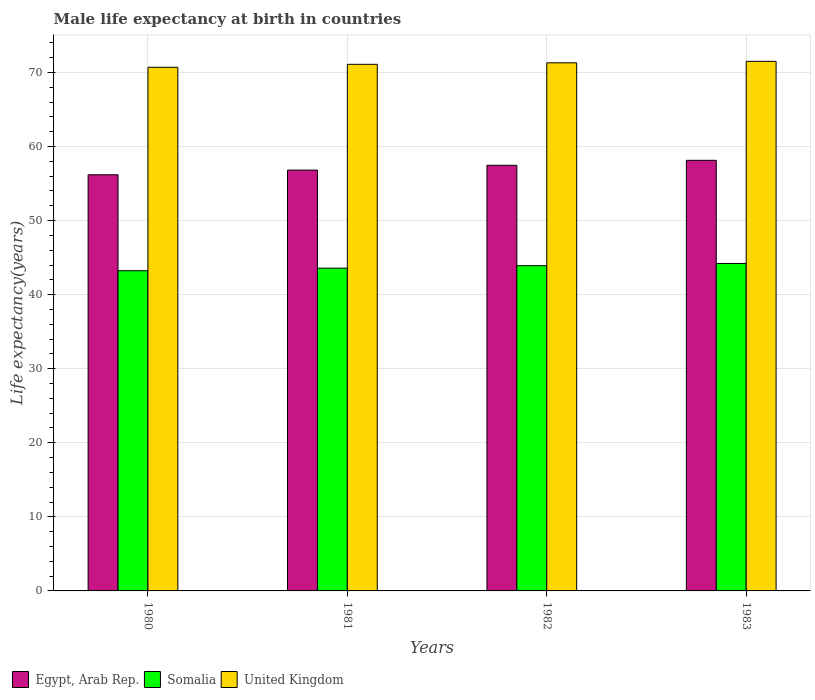Are the number of bars per tick equal to the number of legend labels?
Your answer should be compact. Yes. Are the number of bars on each tick of the X-axis equal?
Make the answer very short. Yes. How many bars are there on the 1st tick from the left?
Offer a terse response. 3. In how many cases, is the number of bars for a given year not equal to the number of legend labels?
Your answer should be very brief. 0. What is the male life expectancy at birth in Somalia in 1982?
Ensure brevity in your answer.  43.91. Across all years, what is the maximum male life expectancy at birth in Egypt, Arab Rep.?
Your response must be concise. 58.14. Across all years, what is the minimum male life expectancy at birth in United Kingdom?
Provide a short and direct response. 70.7. In which year was the male life expectancy at birth in Somalia maximum?
Your answer should be very brief. 1983. What is the total male life expectancy at birth in Somalia in the graph?
Make the answer very short. 174.93. What is the difference between the male life expectancy at birth in Somalia in 1981 and that in 1982?
Give a very brief answer. -0.33. What is the difference between the male life expectancy at birth in United Kingdom in 1981 and the male life expectancy at birth in Somalia in 1982?
Offer a very short reply. 27.19. What is the average male life expectancy at birth in Somalia per year?
Ensure brevity in your answer.  43.73. In the year 1982, what is the difference between the male life expectancy at birth in United Kingdom and male life expectancy at birth in Egypt, Arab Rep.?
Your answer should be compact. 13.84. In how many years, is the male life expectancy at birth in United Kingdom greater than 46 years?
Offer a very short reply. 4. What is the ratio of the male life expectancy at birth in United Kingdom in 1980 to that in 1981?
Make the answer very short. 0.99. Is the difference between the male life expectancy at birth in United Kingdom in 1980 and 1982 greater than the difference between the male life expectancy at birth in Egypt, Arab Rep. in 1980 and 1982?
Keep it short and to the point. Yes. What is the difference between the highest and the second highest male life expectancy at birth in Egypt, Arab Rep.?
Ensure brevity in your answer.  0.67. What is the difference between the highest and the lowest male life expectancy at birth in Somalia?
Ensure brevity in your answer.  0.98. Is the sum of the male life expectancy at birth in United Kingdom in 1980 and 1982 greater than the maximum male life expectancy at birth in Somalia across all years?
Give a very brief answer. Yes. What does the 1st bar from the left in 1982 represents?
Provide a short and direct response. Egypt, Arab Rep. What does the 1st bar from the right in 1981 represents?
Give a very brief answer. United Kingdom. How many bars are there?
Keep it short and to the point. 12. Are all the bars in the graph horizontal?
Make the answer very short. No. Does the graph contain grids?
Your answer should be very brief. Yes. How many legend labels are there?
Keep it short and to the point. 3. What is the title of the graph?
Provide a short and direct response. Male life expectancy at birth in countries. What is the label or title of the Y-axis?
Give a very brief answer. Life expectancy(years). What is the Life expectancy(years) of Egypt, Arab Rep. in 1980?
Make the answer very short. 56.19. What is the Life expectancy(years) in Somalia in 1980?
Provide a succinct answer. 43.23. What is the Life expectancy(years) of United Kingdom in 1980?
Provide a short and direct response. 70.7. What is the Life expectancy(years) in Egypt, Arab Rep. in 1981?
Provide a succinct answer. 56.82. What is the Life expectancy(years) of Somalia in 1981?
Make the answer very short. 43.58. What is the Life expectancy(years) of United Kingdom in 1981?
Your answer should be very brief. 71.1. What is the Life expectancy(years) in Egypt, Arab Rep. in 1982?
Your response must be concise. 57.46. What is the Life expectancy(years) of Somalia in 1982?
Keep it short and to the point. 43.91. What is the Life expectancy(years) in United Kingdom in 1982?
Offer a very short reply. 71.3. What is the Life expectancy(years) of Egypt, Arab Rep. in 1983?
Offer a very short reply. 58.14. What is the Life expectancy(years) in Somalia in 1983?
Provide a succinct answer. 44.21. What is the Life expectancy(years) in United Kingdom in 1983?
Make the answer very short. 71.5. Across all years, what is the maximum Life expectancy(years) in Egypt, Arab Rep.?
Keep it short and to the point. 58.14. Across all years, what is the maximum Life expectancy(years) of Somalia?
Offer a very short reply. 44.21. Across all years, what is the maximum Life expectancy(years) in United Kingdom?
Offer a terse response. 71.5. Across all years, what is the minimum Life expectancy(years) in Egypt, Arab Rep.?
Your answer should be compact. 56.19. Across all years, what is the minimum Life expectancy(years) of Somalia?
Offer a very short reply. 43.23. Across all years, what is the minimum Life expectancy(years) of United Kingdom?
Offer a terse response. 70.7. What is the total Life expectancy(years) in Egypt, Arab Rep. in the graph?
Make the answer very short. 228.61. What is the total Life expectancy(years) in Somalia in the graph?
Offer a terse response. 174.93. What is the total Life expectancy(years) in United Kingdom in the graph?
Your answer should be compact. 284.6. What is the difference between the Life expectancy(years) of Egypt, Arab Rep. in 1980 and that in 1981?
Your answer should be compact. -0.63. What is the difference between the Life expectancy(years) in Somalia in 1980 and that in 1981?
Your answer should be very brief. -0.35. What is the difference between the Life expectancy(years) of Egypt, Arab Rep. in 1980 and that in 1982?
Ensure brevity in your answer.  -1.27. What is the difference between the Life expectancy(years) of Somalia in 1980 and that in 1982?
Your answer should be very brief. -0.68. What is the difference between the Life expectancy(years) of United Kingdom in 1980 and that in 1982?
Keep it short and to the point. -0.6. What is the difference between the Life expectancy(years) in Egypt, Arab Rep. in 1980 and that in 1983?
Offer a terse response. -1.95. What is the difference between the Life expectancy(years) in Somalia in 1980 and that in 1983?
Your answer should be compact. -0.98. What is the difference between the Life expectancy(years) of Egypt, Arab Rep. in 1981 and that in 1982?
Provide a succinct answer. -0.65. What is the difference between the Life expectancy(years) of Somalia in 1981 and that in 1982?
Ensure brevity in your answer.  -0.33. What is the difference between the Life expectancy(years) of United Kingdom in 1981 and that in 1982?
Keep it short and to the point. -0.2. What is the difference between the Life expectancy(years) in Egypt, Arab Rep. in 1981 and that in 1983?
Your answer should be compact. -1.32. What is the difference between the Life expectancy(years) in Somalia in 1981 and that in 1983?
Keep it short and to the point. -0.64. What is the difference between the Life expectancy(years) in United Kingdom in 1981 and that in 1983?
Provide a short and direct response. -0.4. What is the difference between the Life expectancy(years) of Egypt, Arab Rep. in 1982 and that in 1983?
Keep it short and to the point. -0.67. What is the difference between the Life expectancy(years) of Somalia in 1982 and that in 1983?
Ensure brevity in your answer.  -0.3. What is the difference between the Life expectancy(years) in Egypt, Arab Rep. in 1980 and the Life expectancy(years) in Somalia in 1981?
Ensure brevity in your answer.  12.61. What is the difference between the Life expectancy(years) of Egypt, Arab Rep. in 1980 and the Life expectancy(years) of United Kingdom in 1981?
Offer a very short reply. -14.91. What is the difference between the Life expectancy(years) of Somalia in 1980 and the Life expectancy(years) of United Kingdom in 1981?
Provide a succinct answer. -27.87. What is the difference between the Life expectancy(years) of Egypt, Arab Rep. in 1980 and the Life expectancy(years) of Somalia in 1982?
Provide a short and direct response. 12.28. What is the difference between the Life expectancy(years) in Egypt, Arab Rep. in 1980 and the Life expectancy(years) in United Kingdom in 1982?
Your answer should be very brief. -15.11. What is the difference between the Life expectancy(years) of Somalia in 1980 and the Life expectancy(years) of United Kingdom in 1982?
Make the answer very short. -28.07. What is the difference between the Life expectancy(years) in Egypt, Arab Rep. in 1980 and the Life expectancy(years) in Somalia in 1983?
Your answer should be very brief. 11.98. What is the difference between the Life expectancy(years) of Egypt, Arab Rep. in 1980 and the Life expectancy(years) of United Kingdom in 1983?
Your answer should be very brief. -15.31. What is the difference between the Life expectancy(years) in Somalia in 1980 and the Life expectancy(years) in United Kingdom in 1983?
Offer a terse response. -28.27. What is the difference between the Life expectancy(years) of Egypt, Arab Rep. in 1981 and the Life expectancy(years) of Somalia in 1982?
Ensure brevity in your answer.  12.91. What is the difference between the Life expectancy(years) of Egypt, Arab Rep. in 1981 and the Life expectancy(years) of United Kingdom in 1982?
Give a very brief answer. -14.48. What is the difference between the Life expectancy(years) of Somalia in 1981 and the Life expectancy(years) of United Kingdom in 1982?
Give a very brief answer. -27.72. What is the difference between the Life expectancy(years) in Egypt, Arab Rep. in 1981 and the Life expectancy(years) in Somalia in 1983?
Ensure brevity in your answer.  12.61. What is the difference between the Life expectancy(years) in Egypt, Arab Rep. in 1981 and the Life expectancy(years) in United Kingdom in 1983?
Your answer should be very brief. -14.68. What is the difference between the Life expectancy(years) of Somalia in 1981 and the Life expectancy(years) of United Kingdom in 1983?
Provide a short and direct response. -27.92. What is the difference between the Life expectancy(years) of Egypt, Arab Rep. in 1982 and the Life expectancy(years) of Somalia in 1983?
Give a very brief answer. 13.25. What is the difference between the Life expectancy(years) of Egypt, Arab Rep. in 1982 and the Life expectancy(years) of United Kingdom in 1983?
Your response must be concise. -14.04. What is the difference between the Life expectancy(years) of Somalia in 1982 and the Life expectancy(years) of United Kingdom in 1983?
Your answer should be very brief. -27.59. What is the average Life expectancy(years) in Egypt, Arab Rep. per year?
Your response must be concise. 57.15. What is the average Life expectancy(years) in Somalia per year?
Your answer should be compact. 43.73. What is the average Life expectancy(years) in United Kingdom per year?
Offer a very short reply. 71.15. In the year 1980, what is the difference between the Life expectancy(years) of Egypt, Arab Rep. and Life expectancy(years) of Somalia?
Offer a very short reply. 12.96. In the year 1980, what is the difference between the Life expectancy(years) in Egypt, Arab Rep. and Life expectancy(years) in United Kingdom?
Your answer should be very brief. -14.51. In the year 1980, what is the difference between the Life expectancy(years) in Somalia and Life expectancy(years) in United Kingdom?
Your response must be concise. -27.47. In the year 1981, what is the difference between the Life expectancy(years) in Egypt, Arab Rep. and Life expectancy(years) in Somalia?
Provide a short and direct response. 13.24. In the year 1981, what is the difference between the Life expectancy(years) in Egypt, Arab Rep. and Life expectancy(years) in United Kingdom?
Give a very brief answer. -14.28. In the year 1981, what is the difference between the Life expectancy(years) in Somalia and Life expectancy(years) in United Kingdom?
Your response must be concise. -27.52. In the year 1982, what is the difference between the Life expectancy(years) of Egypt, Arab Rep. and Life expectancy(years) of Somalia?
Give a very brief answer. 13.56. In the year 1982, what is the difference between the Life expectancy(years) in Egypt, Arab Rep. and Life expectancy(years) in United Kingdom?
Offer a terse response. -13.84. In the year 1982, what is the difference between the Life expectancy(years) in Somalia and Life expectancy(years) in United Kingdom?
Provide a succinct answer. -27.39. In the year 1983, what is the difference between the Life expectancy(years) in Egypt, Arab Rep. and Life expectancy(years) in Somalia?
Offer a terse response. 13.93. In the year 1983, what is the difference between the Life expectancy(years) of Egypt, Arab Rep. and Life expectancy(years) of United Kingdom?
Your answer should be very brief. -13.36. In the year 1983, what is the difference between the Life expectancy(years) in Somalia and Life expectancy(years) in United Kingdom?
Provide a succinct answer. -27.29. What is the ratio of the Life expectancy(years) in Egypt, Arab Rep. in 1980 to that in 1981?
Keep it short and to the point. 0.99. What is the ratio of the Life expectancy(years) in United Kingdom in 1980 to that in 1981?
Your answer should be very brief. 0.99. What is the ratio of the Life expectancy(years) of Egypt, Arab Rep. in 1980 to that in 1982?
Provide a succinct answer. 0.98. What is the ratio of the Life expectancy(years) of Somalia in 1980 to that in 1982?
Keep it short and to the point. 0.98. What is the ratio of the Life expectancy(years) in United Kingdom in 1980 to that in 1982?
Make the answer very short. 0.99. What is the ratio of the Life expectancy(years) in Egypt, Arab Rep. in 1980 to that in 1983?
Your answer should be compact. 0.97. What is the ratio of the Life expectancy(years) of Somalia in 1980 to that in 1983?
Give a very brief answer. 0.98. What is the ratio of the Life expectancy(years) of United Kingdom in 1981 to that in 1982?
Provide a succinct answer. 1. What is the ratio of the Life expectancy(years) in Egypt, Arab Rep. in 1981 to that in 1983?
Ensure brevity in your answer.  0.98. What is the ratio of the Life expectancy(years) in Somalia in 1981 to that in 1983?
Provide a short and direct response. 0.99. What is the ratio of the Life expectancy(years) of United Kingdom in 1981 to that in 1983?
Your answer should be very brief. 0.99. What is the ratio of the Life expectancy(years) in Egypt, Arab Rep. in 1982 to that in 1983?
Keep it short and to the point. 0.99. What is the ratio of the Life expectancy(years) of United Kingdom in 1982 to that in 1983?
Offer a very short reply. 1. What is the difference between the highest and the second highest Life expectancy(years) of Egypt, Arab Rep.?
Provide a short and direct response. 0.67. What is the difference between the highest and the second highest Life expectancy(years) in Somalia?
Your answer should be very brief. 0.3. What is the difference between the highest and the second highest Life expectancy(years) of United Kingdom?
Provide a succinct answer. 0.2. What is the difference between the highest and the lowest Life expectancy(years) in Egypt, Arab Rep.?
Keep it short and to the point. 1.95. What is the difference between the highest and the lowest Life expectancy(years) in Somalia?
Give a very brief answer. 0.98. What is the difference between the highest and the lowest Life expectancy(years) in United Kingdom?
Make the answer very short. 0.8. 